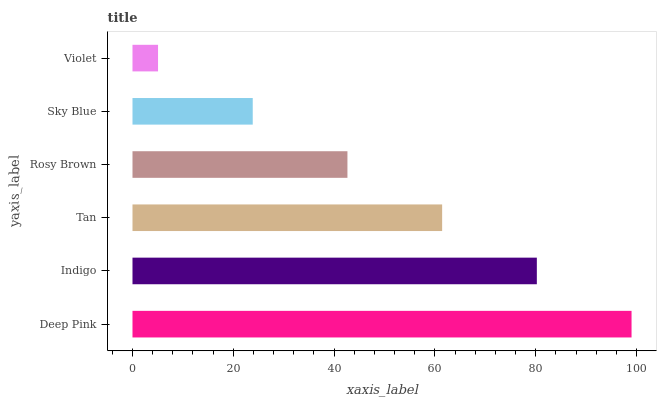Is Violet the minimum?
Answer yes or no. Yes. Is Deep Pink the maximum?
Answer yes or no. Yes. Is Indigo the minimum?
Answer yes or no. No. Is Indigo the maximum?
Answer yes or no. No. Is Deep Pink greater than Indigo?
Answer yes or no. Yes. Is Indigo less than Deep Pink?
Answer yes or no. Yes. Is Indigo greater than Deep Pink?
Answer yes or no. No. Is Deep Pink less than Indigo?
Answer yes or no. No. Is Tan the high median?
Answer yes or no. Yes. Is Rosy Brown the low median?
Answer yes or no. Yes. Is Violet the high median?
Answer yes or no. No. Is Indigo the low median?
Answer yes or no. No. 